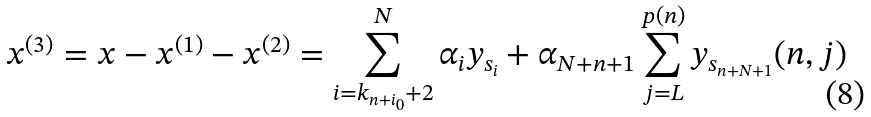Convert formula to latex. <formula><loc_0><loc_0><loc_500><loc_500>x ^ { ( 3 ) } = x - x ^ { ( 1 ) } - x ^ { ( 2 ) } = \sum _ { i = k _ { n + i _ { 0 } } + 2 } ^ { N } \alpha _ { i } y _ { s _ { i } } + \alpha _ { N + n + 1 } \sum _ { j = L } ^ { p ( n ) } y _ { s _ { n + N + 1 } } ( n , j )</formula> 